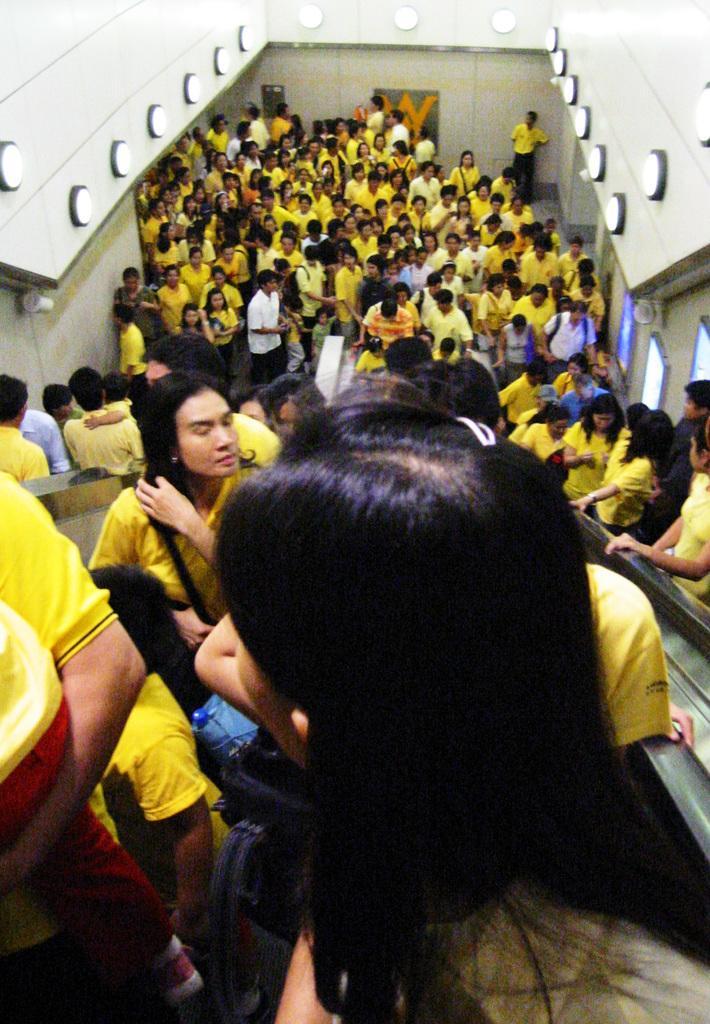Describe this image in one or two sentences. In this image there are a so many people standing and few are standing on the escalator. 